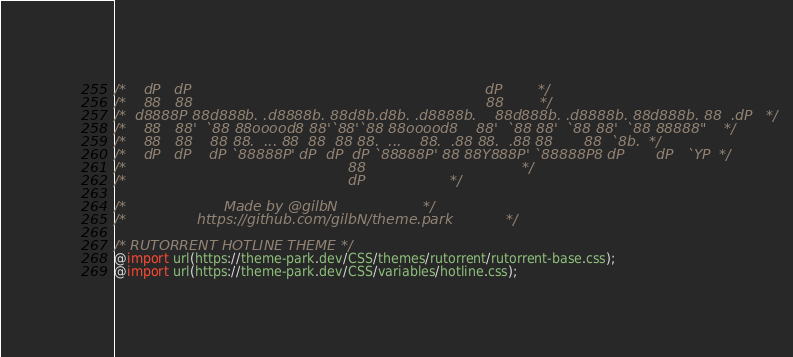<code> <loc_0><loc_0><loc_500><loc_500><_CSS_>
/*    dP   dP                                                                  dP        */
/*    88   88                                                                  88        */
/*  d8888P 88d888b. .d8888b. 88d8b.d8b. .d8888b.    88d888b. .d8888b. 88d888b. 88  .dP   */
/*    88   88'  `88 88ooood8 88'`88'`88 88ooood8    88'  `88 88'  `88 88'  `88 88888"    */
/*    88   88    88 88.  ... 88  88  88 88.  ...    88.  .88 88.  .88 88       88  `8b.  */
/*    dP   dP    dP `88888P' dP  dP  dP `88888P' 88 88Y888P' `88888P8 dP       dP   `YP  */
/*                                                  88                                   */
/*                                                  dP					 */

/*		   		        Made by @gilbN					 */
/*			      https://github.com/gilbN/theme.park			 */

/* RUTORRENT HOTLINE THEME */
@import url(https://theme-park.dev/CSS/themes/rutorrent/rutorrent-base.css);
@import url(https://theme-park.dev/CSS/variables/hotline.css);</code> 